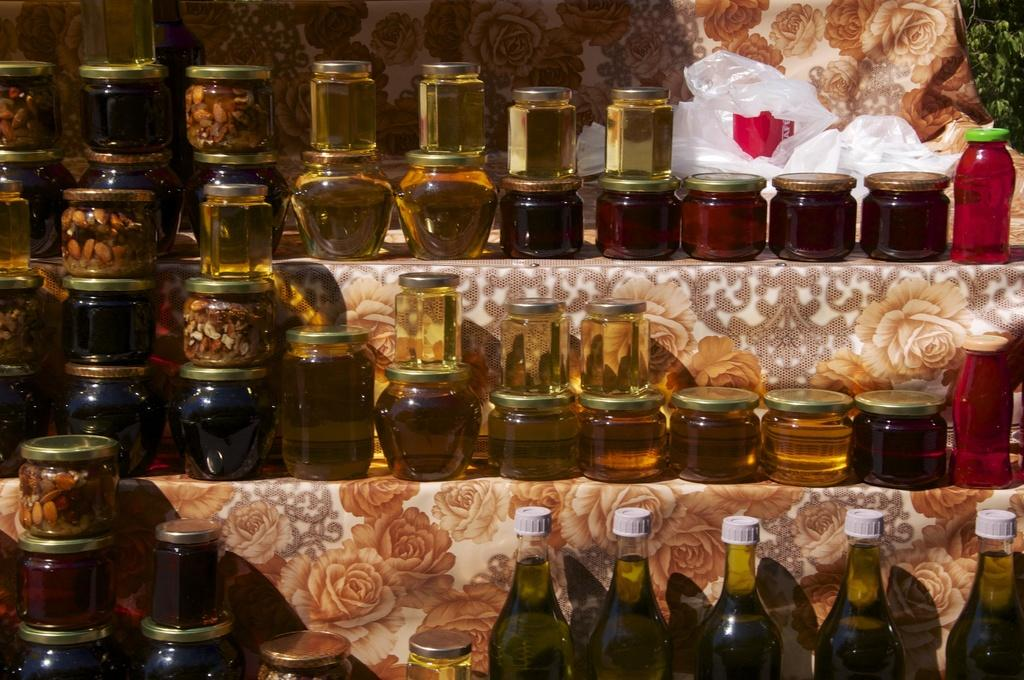What type of containers are visible in the image? There are glass bottles and jars with some liquids in the image. Can you describe the contents of the containers? The jars contain some liquids, but the specific contents are not mentioned in the facts. How many men are participating in the battle depicted in the image? There is no battle or men present in the image; it features glass bottles and jars with liquids. 